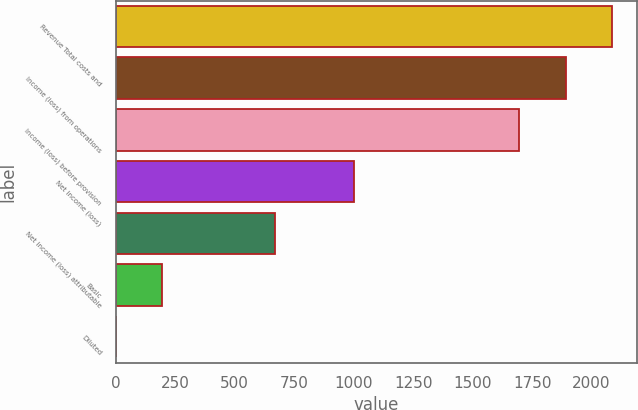Convert chart. <chart><loc_0><loc_0><loc_500><loc_500><bar_chart><fcel>Revenue Total costs and<fcel>Income (loss) from operations<fcel>Income (loss) before provision<fcel>Net income (loss)<fcel>Net income (loss) attributable<fcel>Basic<fcel>Diluted<nl><fcel>2085.9<fcel>1890.45<fcel>1695<fcel>1000<fcel>668<fcel>195.91<fcel>0.46<nl></chart> 